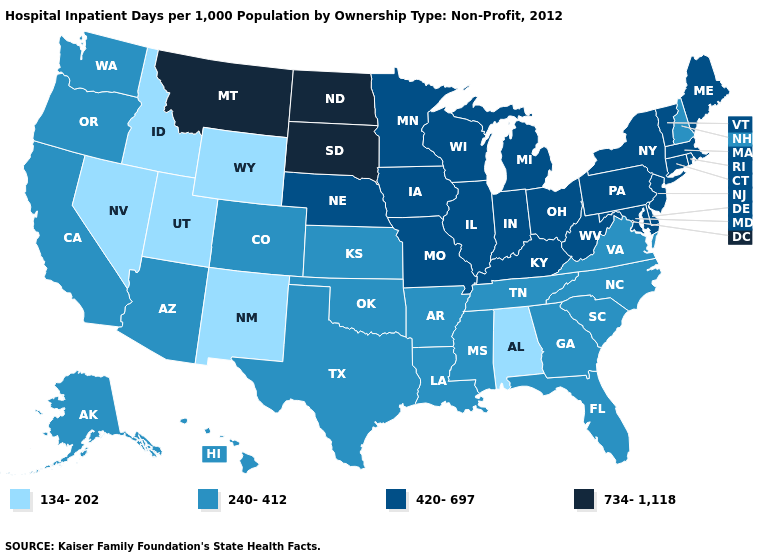What is the value of Tennessee?
Answer briefly. 240-412. Does Kansas have the lowest value in the MidWest?
Answer briefly. Yes. What is the value of California?
Write a very short answer. 240-412. Among the states that border Washington , which have the lowest value?
Give a very brief answer. Idaho. Among the states that border Washington , does Oregon have the lowest value?
Quick response, please. No. Name the states that have a value in the range 420-697?
Quick response, please. Connecticut, Delaware, Illinois, Indiana, Iowa, Kentucky, Maine, Maryland, Massachusetts, Michigan, Minnesota, Missouri, Nebraska, New Jersey, New York, Ohio, Pennsylvania, Rhode Island, Vermont, West Virginia, Wisconsin. Does the first symbol in the legend represent the smallest category?
Give a very brief answer. Yes. Does Oklahoma have a lower value than Minnesota?
Write a very short answer. Yes. What is the value of Montana?
Short answer required. 734-1,118. What is the value of Maryland?
Be succinct. 420-697. Which states have the lowest value in the South?
Write a very short answer. Alabama. Does New Hampshire have the lowest value in the Northeast?
Short answer required. Yes. What is the highest value in states that border South Carolina?
Give a very brief answer. 240-412. What is the highest value in states that border West Virginia?
Be succinct. 420-697. Name the states that have a value in the range 420-697?
Give a very brief answer. Connecticut, Delaware, Illinois, Indiana, Iowa, Kentucky, Maine, Maryland, Massachusetts, Michigan, Minnesota, Missouri, Nebraska, New Jersey, New York, Ohio, Pennsylvania, Rhode Island, Vermont, West Virginia, Wisconsin. 